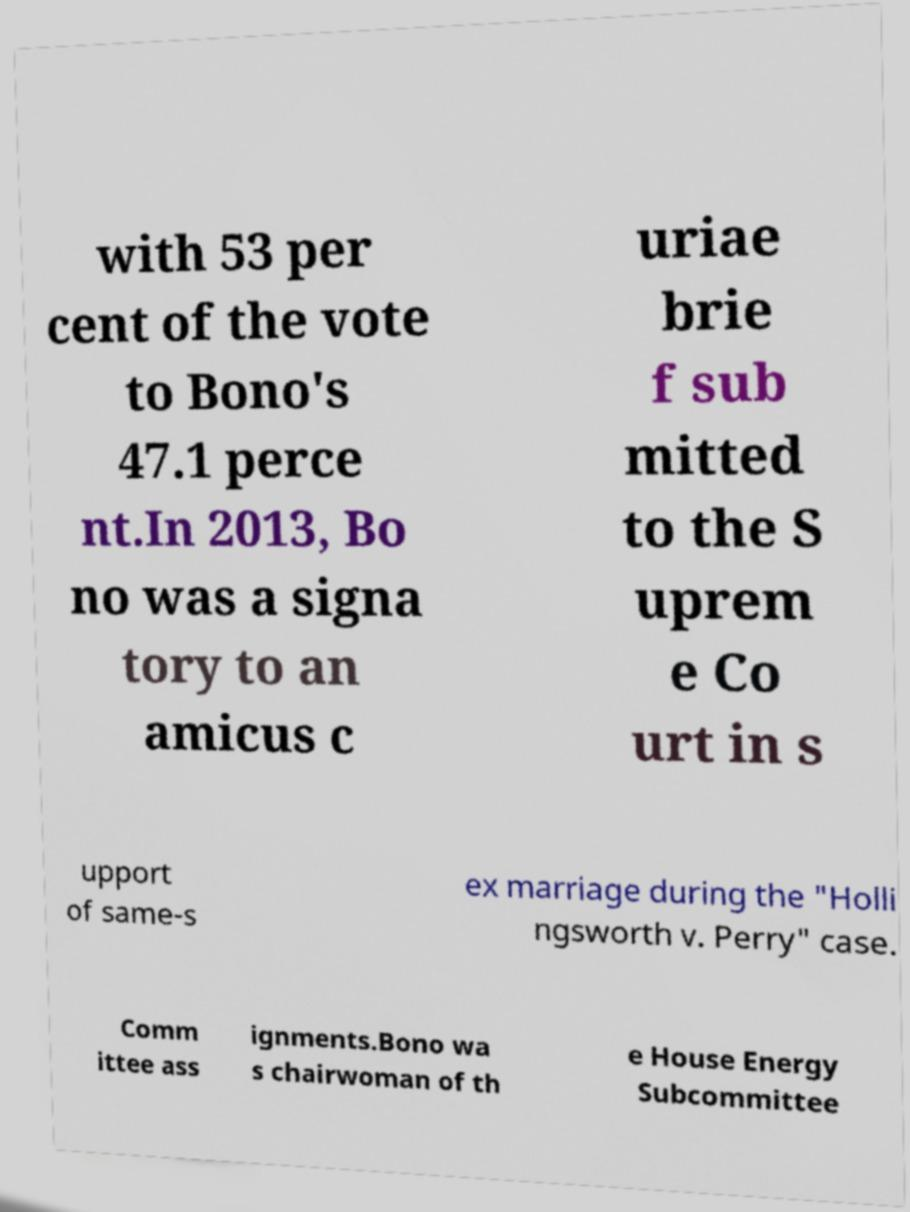Could you assist in decoding the text presented in this image and type it out clearly? with 53 per cent of the vote to Bono's 47.1 perce nt.In 2013, Bo no was a signa tory to an amicus c uriae brie f sub mitted to the S uprem e Co urt in s upport of same-s ex marriage during the "Holli ngsworth v. Perry" case. Comm ittee ass ignments.Bono wa s chairwoman of th e House Energy Subcommittee 